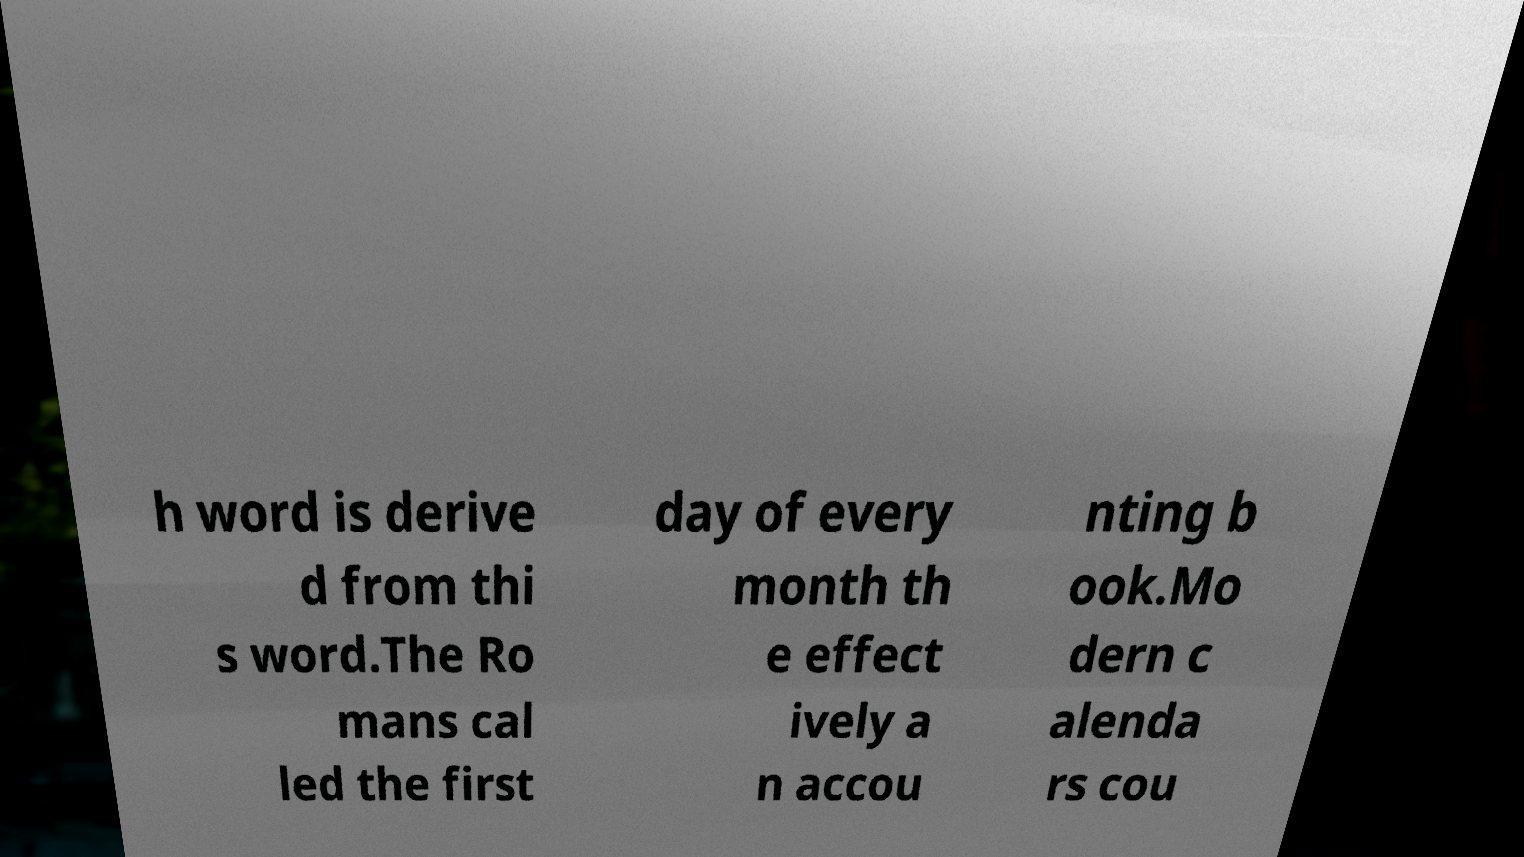Could you extract and type out the text from this image? h word is derive d from thi s word.The Ro mans cal led the first day of every month th e effect ively a n accou nting b ook.Mo dern c alenda rs cou 